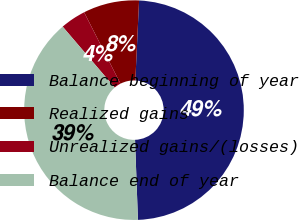Convert chart. <chart><loc_0><loc_0><loc_500><loc_500><pie_chart><fcel>Balance beginning of year<fcel>Realized gains<fcel>Unrealized gains/(losses)<fcel>Balance end of year<nl><fcel>48.69%<fcel>8.24%<fcel>3.75%<fcel>39.33%<nl></chart> 